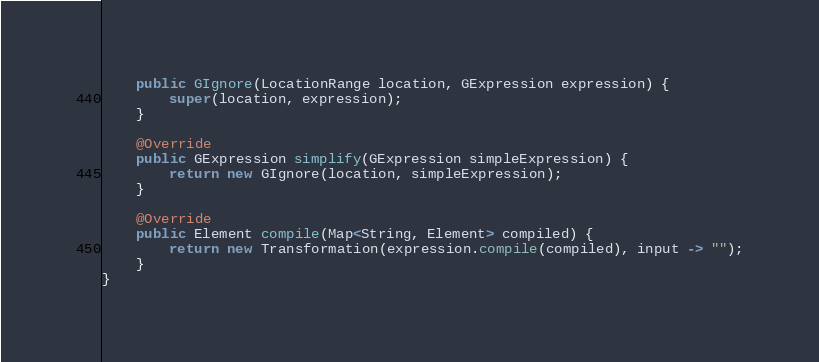Convert code to text. <code><loc_0><loc_0><loc_500><loc_500><_Java_>
    public GIgnore(LocationRange location, GExpression expression) {
        super(location, expression);
    }

    @Override
    public GExpression simplify(GExpression simpleExpression) {
        return new GIgnore(location, simpleExpression);
    }

    @Override
    public Element compile(Map<String, Element> compiled) {
        return new Transformation(expression.compile(compiled), input -> "");
    }
}
</code> 